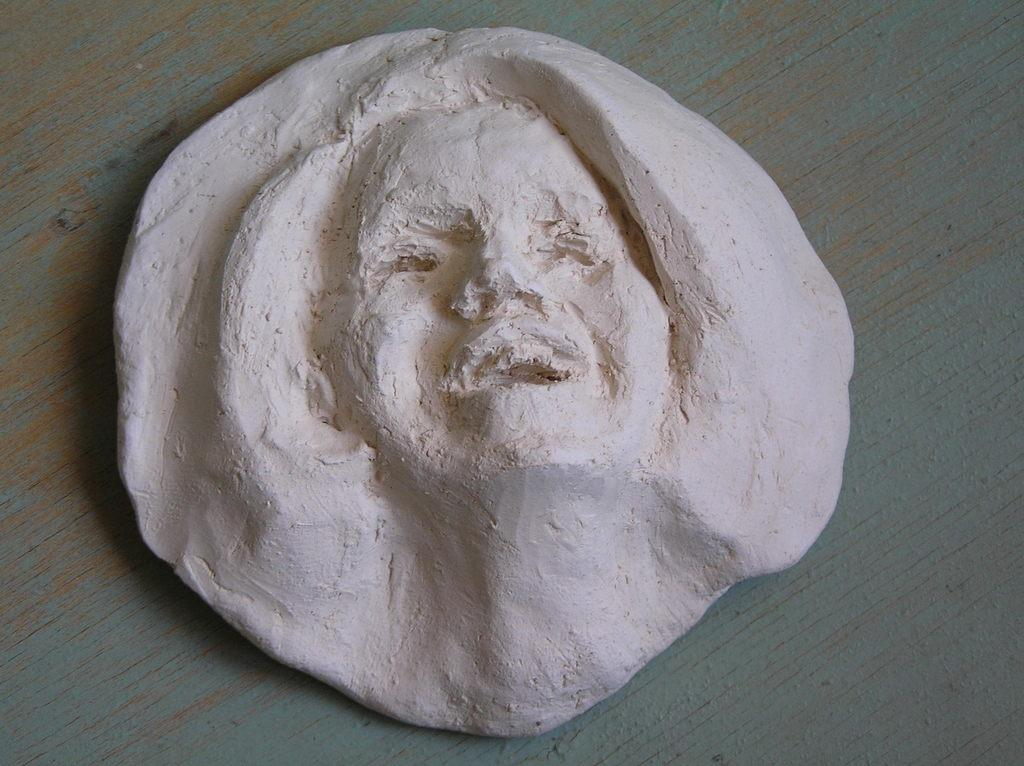What is the main object in the image? There is a white and cream color object in the image. What can be seen on the object? There is a person depicted on the object. What is the color of the surface the object is placed on? The object is on a grey and brown color surface. How many balls are being used in the science experiment depicted in the image? There is no science experiment or balls present in the image; it features a white and cream color object with a person depicted on it. 